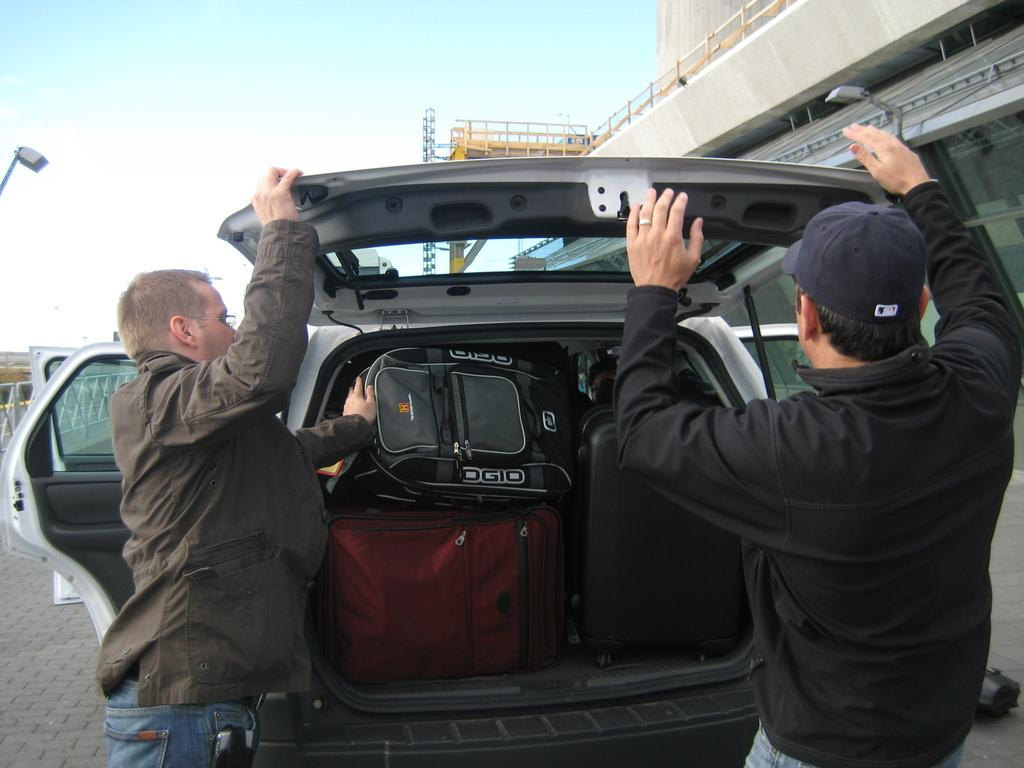What is the main subject of the image? The main subject of the image is a vehicle with luggage bags. Where is the vehicle located? The vehicle is on the ground. Can you describe the people in the image? There are people in the image, but their specific actions or appearances are not mentioned in the facts. What type of structure can be seen in the image? There is a building in the image. What other objects are present in the image? There is a fence and some unspecified objects in the image. What can be seen in the background of the image? The sky is visible in the background of the image. What type of chair is being used to cover the vehicle in the image? There is no chair present in the image, nor is there any indication that the vehicle is being covered. 